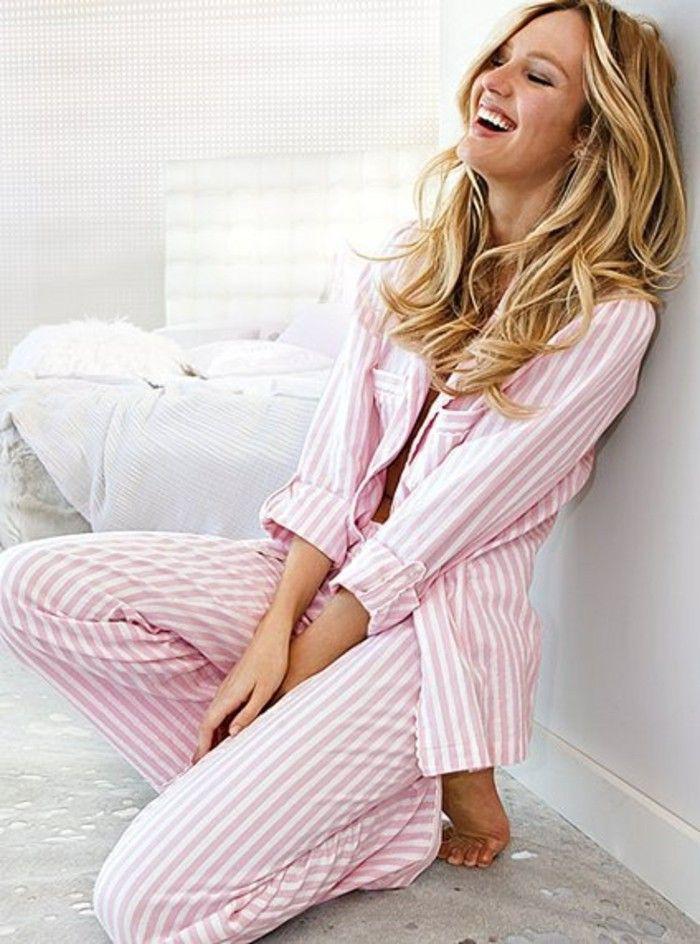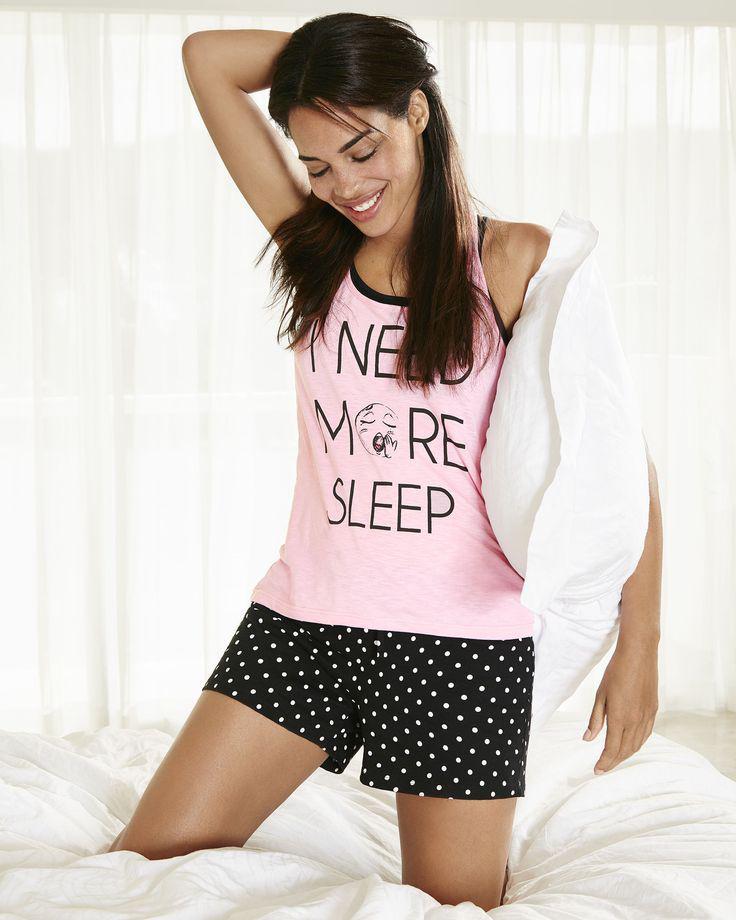The first image is the image on the left, the second image is the image on the right. For the images displayed, is the sentence "An image features a model wearing matching white pajamas printed with rosy flowers and green leaves." factually correct? Answer yes or no. No. The first image is the image on the left, the second image is the image on the right. Evaluate the accuracy of this statement regarding the images: "The woman in one of the images has at least one hand on her knee.". Is it true? Answer yes or no. No. 